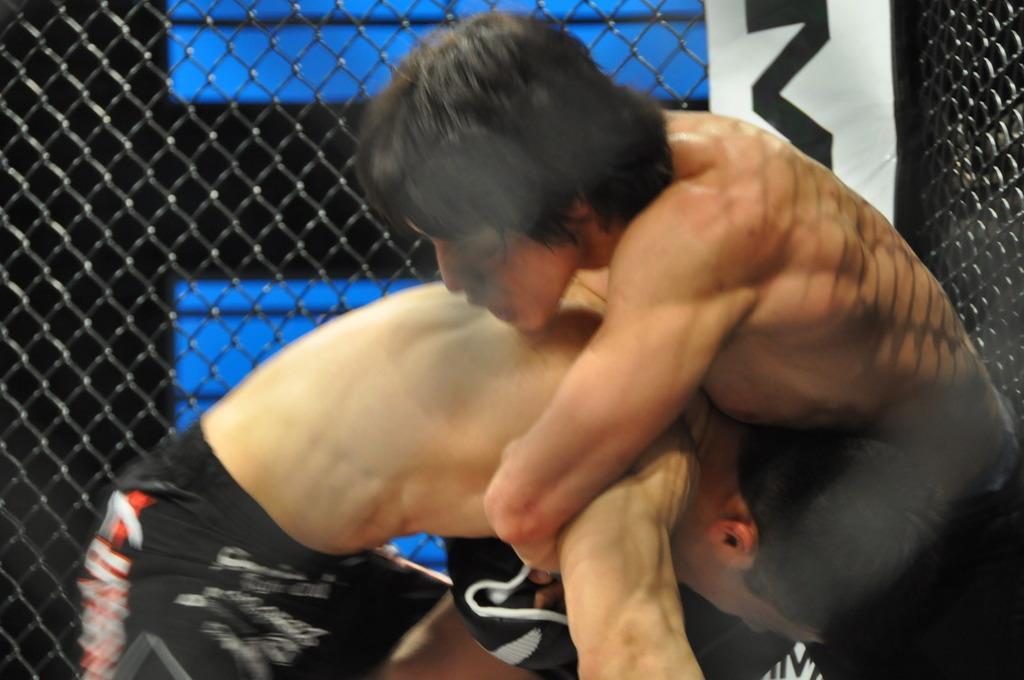Can you describe this image briefly? In this picture we can see two men holding each other and beside them we can see a poster, mesh and in the background we can see the wall. 